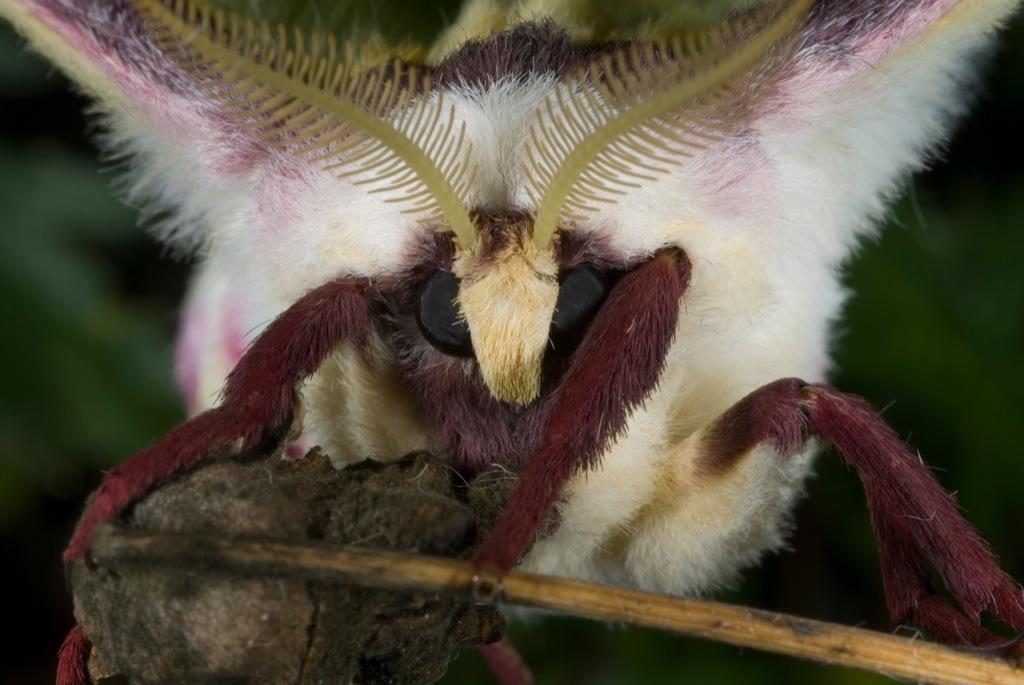Please provide a concise description of this image. This picture contains an insect in white color. In the background, it is green in color and it is blurred in the background. 